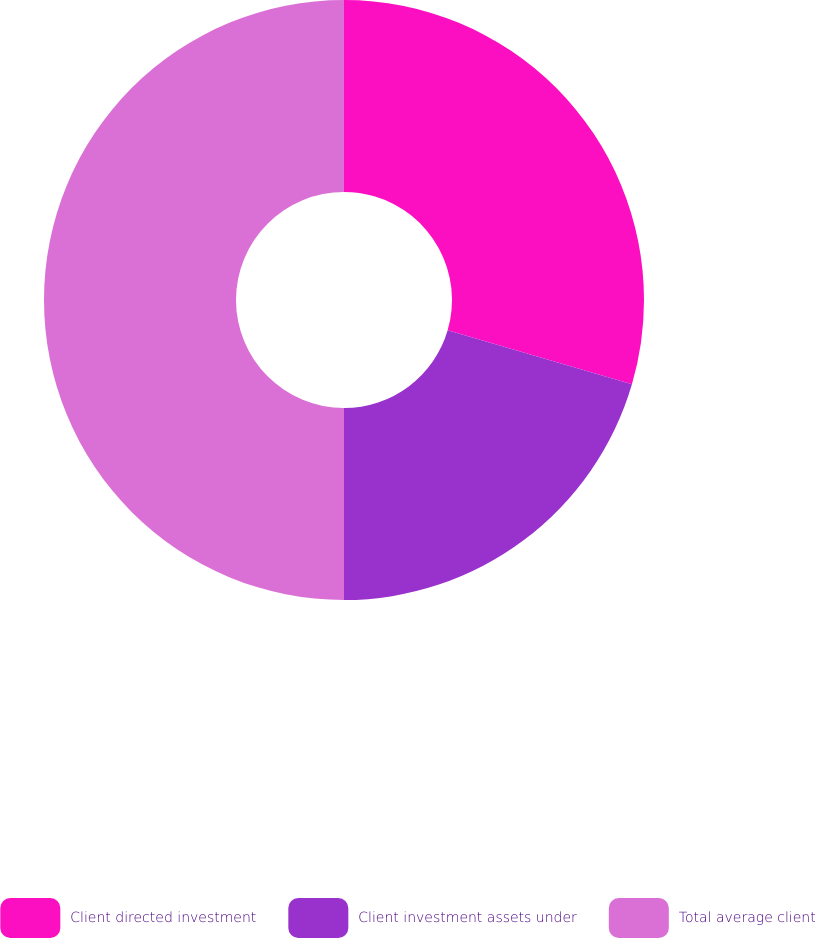Convert chart to OTSL. <chart><loc_0><loc_0><loc_500><loc_500><pie_chart><fcel>Client directed investment<fcel>Client investment assets under<fcel>Total average client<nl><fcel>29.53%<fcel>20.47%<fcel>50.0%<nl></chart> 